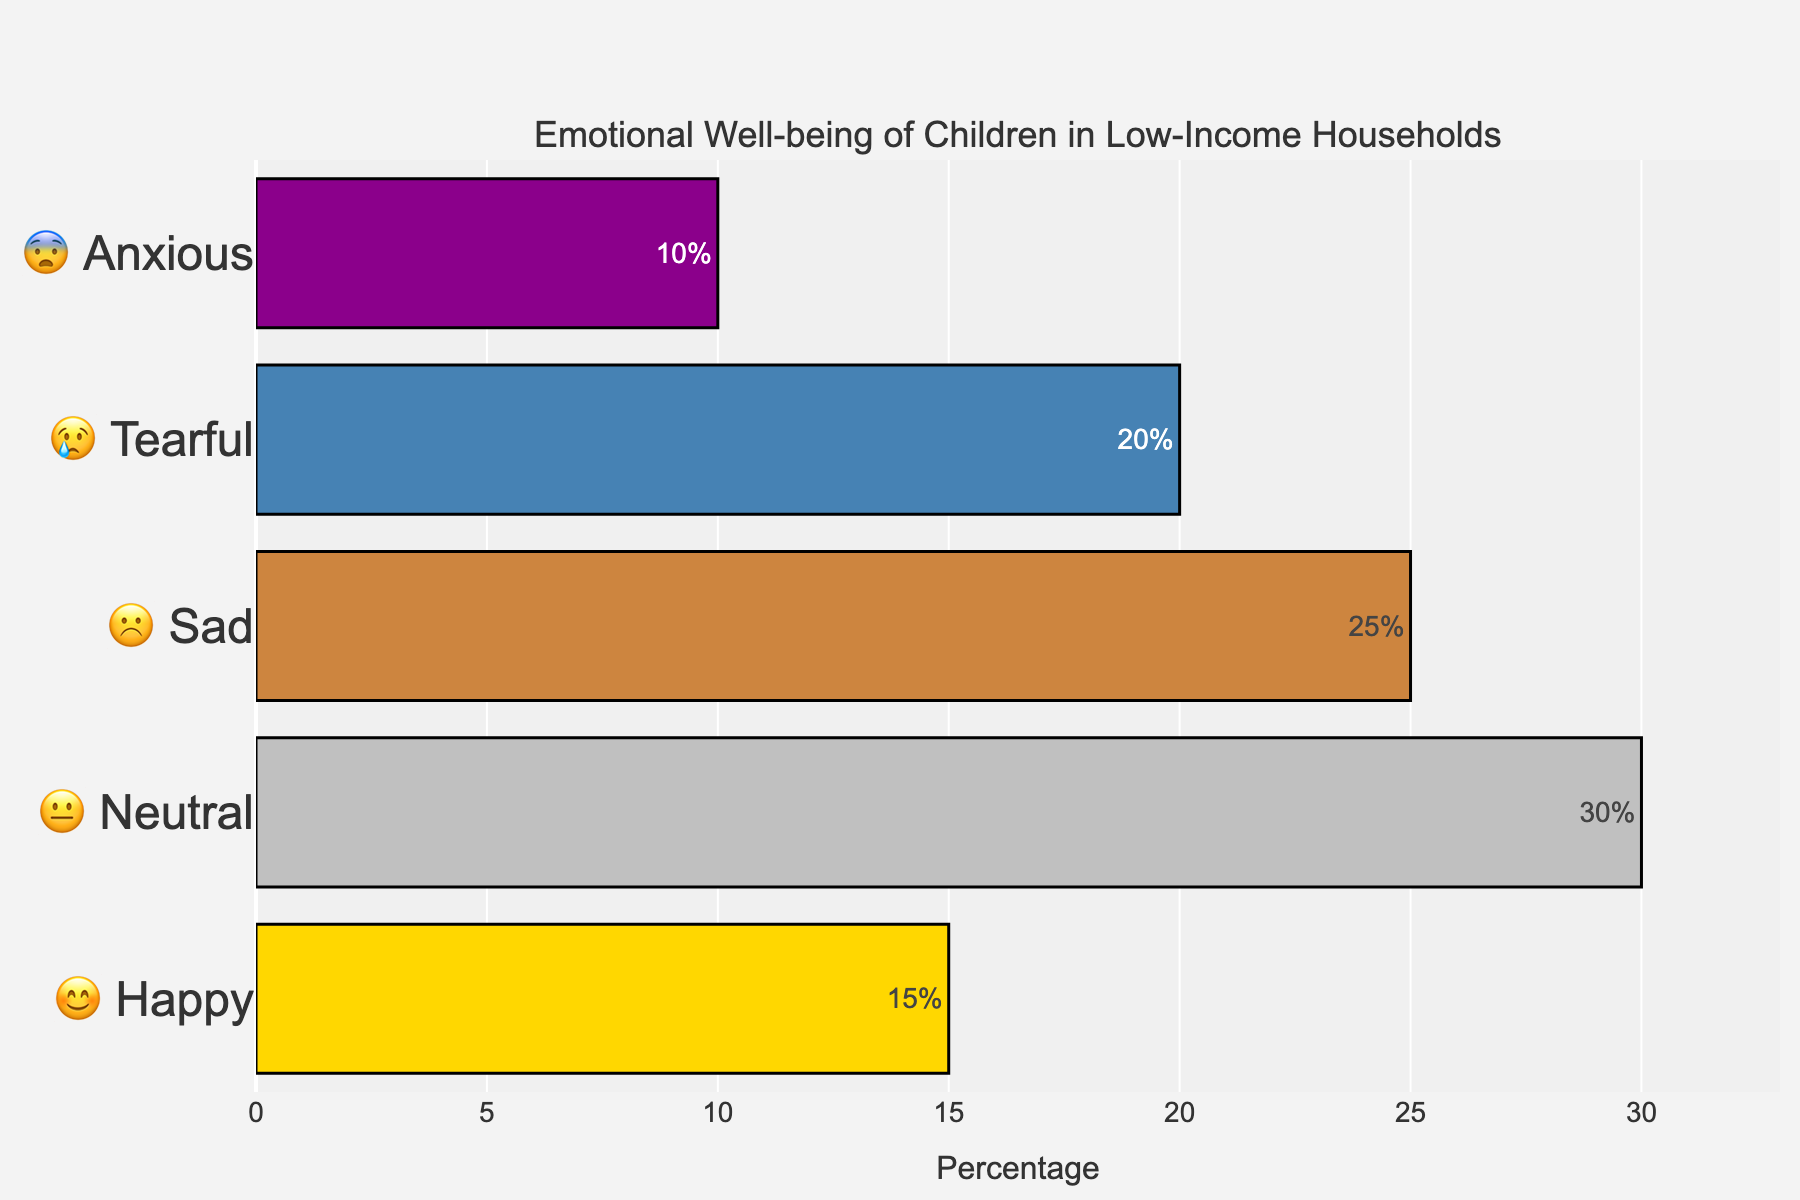What's the title of the chart? The title is typically displayed at the top of the chart, providing an overall description of the data being represented.
Answer: Emotional Well-being of Children in Low-Income Households What emotion represents the highest percentage? To find the emotion with the highest percentage, look at the bar that extends the furthest to the right.
Answer: 😐 Neutral Which emotion has the smallest representation? Identify the shortest bar on the chart to find the emotion with the smallest percentage.
Answer: 😨 Anxious What's the combined percentage of children who feel Sad and Tearful? Add the percentage values for Sad (25%) and Tearful (20%). 25 + 20 = 45
Answer: 45% How much higher is the percentage of Neutral than Anxious? Subtract the percentage for Anxious (10%) from the percentage for Neutral (30%). 30 - 10 = 20
Answer: 20% Arrange the emotions from highest to lowest percentage. Order the emotions based on the length of their bars from longest to shortest.
Answer: Neutral, Sad, Tearful, Happy, Anxious What's the average percentage across all emotions shown? Calculate the mean by adding all percentages and dividing by the number of data points. Sum is (15 + 30 + 25 + 20 + 10) = 100, then 100 / 5 = 20
Answer: 20% Which two emotions have double digits in their percentages but less than 25%? Look for bars with percentage values in double digits but below 25%. These are Happy (15%), and Anxious (10%).
Answer: Happy and Anxious Between Happy and Tearful, which emotion has a higher percentage? Compare the length of the bars for Happy (15%) and Tearful (20%).
Answer: 😢 Tearful What percentage of children do not feel Happy or Tearful? Subtract the percentages of Happy (15%) and Tearful (20%) from 100%. (100 - 15 - 20) = 65
Answer: 65% 